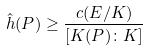<formula> <loc_0><loc_0><loc_500><loc_500>\hat { h } ( P ) \geq \frac { c ( E / K ) } { [ K ( P ) \colon K ] }</formula> 